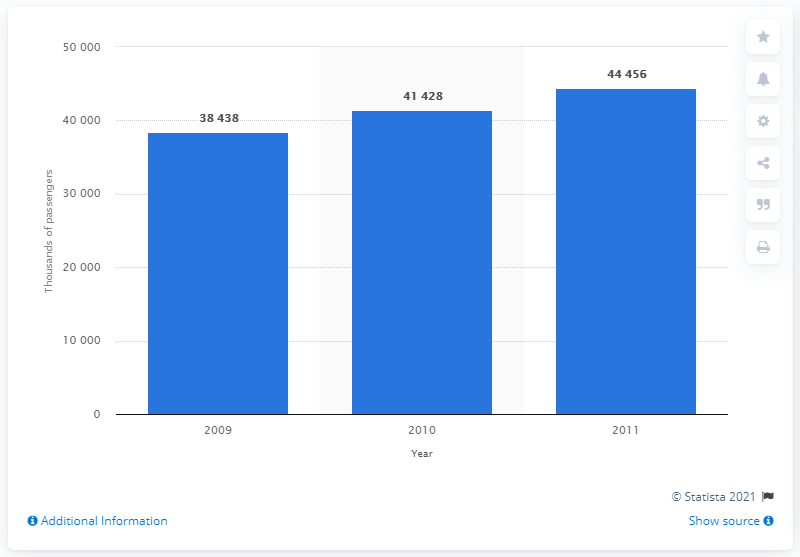Outline some significant characteristics in this image. The Qantas Group's last fiscal year of worldwide passenger numbers was in 2009. 